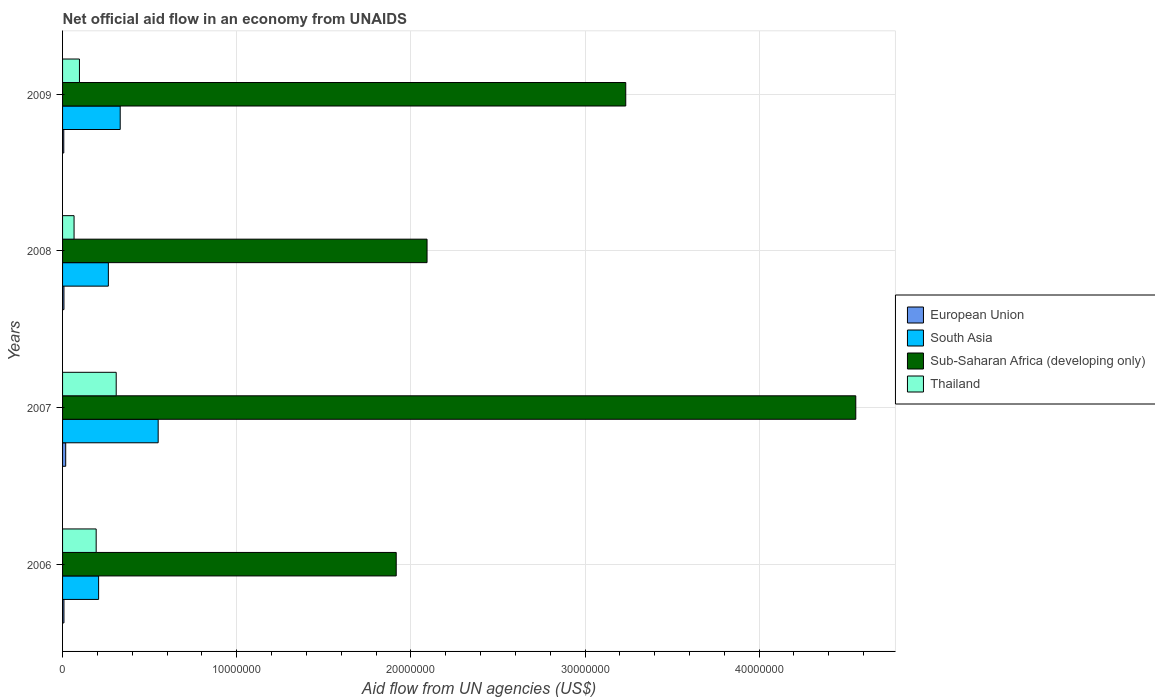How many groups of bars are there?
Offer a terse response. 4. Are the number of bars on each tick of the Y-axis equal?
Offer a terse response. Yes. How many bars are there on the 1st tick from the top?
Provide a succinct answer. 4. Across all years, what is the maximum net official aid flow in South Asia?
Your response must be concise. 5.49e+06. Across all years, what is the minimum net official aid flow in Sub-Saharan Africa (developing only)?
Give a very brief answer. 1.92e+07. What is the total net official aid flow in European Union in the graph?
Your response must be concise. 4.10e+05. What is the difference between the net official aid flow in Sub-Saharan Africa (developing only) in 2007 and that in 2009?
Give a very brief answer. 1.32e+07. What is the difference between the net official aid flow in European Union in 2006 and the net official aid flow in Sub-Saharan Africa (developing only) in 2008?
Keep it short and to the point. -2.08e+07. What is the average net official aid flow in European Union per year?
Ensure brevity in your answer.  1.02e+05. In the year 2008, what is the difference between the net official aid flow in Sub-Saharan Africa (developing only) and net official aid flow in European Union?
Make the answer very short. 2.08e+07. What is the ratio of the net official aid flow in European Union in 2008 to that in 2009?
Your answer should be very brief. 1.14. Is the net official aid flow in South Asia in 2006 less than that in 2009?
Your answer should be very brief. Yes. Is the difference between the net official aid flow in Sub-Saharan Africa (developing only) in 2006 and 2008 greater than the difference between the net official aid flow in European Union in 2006 and 2008?
Ensure brevity in your answer.  No. What is the difference between the highest and the lowest net official aid flow in South Asia?
Your answer should be compact. 3.42e+06. In how many years, is the net official aid flow in Thailand greater than the average net official aid flow in Thailand taken over all years?
Your response must be concise. 2. Is the sum of the net official aid flow in South Asia in 2007 and 2009 greater than the maximum net official aid flow in Sub-Saharan Africa (developing only) across all years?
Offer a very short reply. No. Is it the case that in every year, the sum of the net official aid flow in Thailand and net official aid flow in European Union is greater than the sum of net official aid flow in Sub-Saharan Africa (developing only) and net official aid flow in South Asia?
Offer a terse response. Yes. What does the 2nd bar from the top in 2008 represents?
Provide a short and direct response. Sub-Saharan Africa (developing only). Is it the case that in every year, the sum of the net official aid flow in South Asia and net official aid flow in Thailand is greater than the net official aid flow in European Union?
Keep it short and to the point. Yes. How many bars are there?
Give a very brief answer. 16. Does the graph contain grids?
Offer a very short reply. Yes. Where does the legend appear in the graph?
Give a very brief answer. Center right. How are the legend labels stacked?
Make the answer very short. Vertical. What is the title of the graph?
Ensure brevity in your answer.  Net official aid flow in an economy from UNAIDS. What is the label or title of the X-axis?
Keep it short and to the point. Aid flow from UN agencies (US$). What is the label or title of the Y-axis?
Offer a terse response. Years. What is the Aid flow from UN agencies (US$) of European Union in 2006?
Provide a short and direct response. 8.00e+04. What is the Aid flow from UN agencies (US$) of South Asia in 2006?
Offer a terse response. 2.07e+06. What is the Aid flow from UN agencies (US$) of Sub-Saharan Africa (developing only) in 2006?
Your answer should be compact. 1.92e+07. What is the Aid flow from UN agencies (US$) in Thailand in 2006?
Your response must be concise. 1.93e+06. What is the Aid flow from UN agencies (US$) in South Asia in 2007?
Your answer should be very brief. 5.49e+06. What is the Aid flow from UN agencies (US$) in Sub-Saharan Africa (developing only) in 2007?
Ensure brevity in your answer.  4.56e+07. What is the Aid flow from UN agencies (US$) in Thailand in 2007?
Provide a succinct answer. 3.08e+06. What is the Aid flow from UN agencies (US$) of European Union in 2008?
Offer a very short reply. 8.00e+04. What is the Aid flow from UN agencies (US$) of South Asia in 2008?
Offer a very short reply. 2.63e+06. What is the Aid flow from UN agencies (US$) of Sub-Saharan Africa (developing only) in 2008?
Your response must be concise. 2.09e+07. What is the Aid flow from UN agencies (US$) of European Union in 2009?
Your answer should be very brief. 7.00e+04. What is the Aid flow from UN agencies (US$) of South Asia in 2009?
Your answer should be very brief. 3.31e+06. What is the Aid flow from UN agencies (US$) of Sub-Saharan Africa (developing only) in 2009?
Make the answer very short. 3.23e+07. What is the Aid flow from UN agencies (US$) of Thailand in 2009?
Give a very brief answer. 9.70e+05. Across all years, what is the maximum Aid flow from UN agencies (US$) of South Asia?
Offer a terse response. 5.49e+06. Across all years, what is the maximum Aid flow from UN agencies (US$) of Sub-Saharan Africa (developing only)?
Offer a terse response. 4.56e+07. Across all years, what is the maximum Aid flow from UN agencies (US$) of Thailand?
Ensure brevity in your answer.  3.08e+06. Across all years, what is the minimum Aid flow from UN agencies (US$) of European Union?
Your response must be concise. 7.00e+04. Across all years, what is the minimum Aid flow from UN agencies (US$) in South Asia?
Keep it short and to the point. 2.07e+06. Across all years, what is the minimum Aid flow from UN agencies (US$) of Sub-Saharan Africa (developing only)?
Keep it short and to the point. 1.92e+07. What is the total Aid flow from UN agencies (US$) in South Asia in the graph?
Ensure brevity in your answer.  1.35e+07. What is the total Aid flow from UN agencies (US$) of Sub-Saharan Africa (developing only) in the graph?
Offer a very short reply. 1.18e+08. What is the total Aid flow from UN agencies (US$) of Thailand in the graph?
Offer a terse response. 6.64e+06. What is the difference between the Aid flow from UN agencies (US$) of South Asia in 2006 and that in 2007?
Your answer should be very brief. -3.42e+06. What is the difference between the Aid flow from UN agencies (US$) of Sub-Saharan Africa (developing only) in 2006 and that in 2007?
Make the answer very short. -2.64e+07. What is the difference between the Aid flow from UN agencies (US$) in Thailand in 2006 and that in 2007?
Ensure brevity in your answer.  -1.15e+06. What is the difference between the Aid flow from UN agencies (US$) of South Asia in 2006 and that in 2008?
Offer a very short reply. -5.60e+05. What is the difference between the Aid flow from UN agencies (US$) in Sub-Saharan Africa (developing only) in 2006 and that in 2008?
Ensure brevity in your answer.  -1.77e+06. What is the difference between the Aid flow from UN agencies (US$) in Thailand in 2006 and that in 2008?
Offer a terse response. 1.27e+06. What is the difference between the Aid flow from UN agencies (US$) in European Union in 2006 and that in 2009?
Your response must be concise. 10000. What is the difference between the Aid flow from UN agencies (US$) in South Asia in 2006 and that in 2009?
Keep it short and to the point. -1.24e+06. What is the difference between the Aid flow from UN agencies (US$) in Sub-Saharan Africa (developing only) in 2006 and that in 2009?
Give a very brief answer. -1.32e+07. What is the difference between the Aid flow from UN agencies (US$) of Thailand in 2006 and that in 2009?
Give a very brief answer. 9.60e+05. What is the difference between the Aid flow from UN agencies (US$) of South Asia in 2007 and that in 2008?
Provide a short and direct response. 2.86e+06. What is the difference between the Aid flow from UN agencies (US$) of Sub-Saharan Africa (developing only) in 2007 and that in 2008?
Offer a very short reply. 2.46e+07. What is the difference between the Aid flow from UN agencies (US$) in Thailand in 2007 and that in 2008?
Ensure brevity in your answer.  2.42e+06. What is the difference between the Aid flow from UN agencies (US$) in European Union in 2007 and that in 2009?
Provide a succinct answer. 1.10e+05. What is the difference between the Aid flow from UN agencies (US$) of South Asia in 2007 and that in 2009?
Ensure brevity in your answer.  2.18e+06. What is the difference between the Aid flow from UN agencies (US$) of Sub-Saharan Africa (developing only) in 2007 and that in 2009?
Make the answer very short. 1.32e+07. What is the difference between the Aid flow from UN agencies (US$) in Thailand in 2007 and that in 2009?
Keep it short and to the point. 2.11e+06. What is the difference between the Aid flow from UN agencies (US$) of South Asia in 2008 and that in 2009?
Your answer should be very brief. -6.80e+05. What is the difference between the Aid flow from UN agencies (US$) of Sub-Saharan Africa (developing only) in 2008 and that in 2009?
Give a very brief answer. -1.14e+07. What is the difference between the Aid flow from UN agencies (US$) in Thailand in 2008 and that in 2009?
Offer a very short reply. -3.10e+05. What is the difference between the Aid flow from UN agencies (US$) in European Union in 2006 and the Aid flow from UN agencies (US$) in South Asia in 2007?
Your answer should be very brief. -5.41e+06. What is the difference between the Aid flow from UN agencies (US$) of European Union in 2006 and the Aid flow from UN agencies (US$) of Sub-Saharan Africa (developing only) in 2007?
Keep it short and to the point. -4.55e+07. What is the difference between the Aid flow from UN agencies (US$) of European Union in 2006 and the Aid flow from UN agencies (US$) of Thailand in 2007?
Your response must be concise. -3.00e+06. What is the difference between the Aid flow from UN agencies (US$) of South Asia in 2006 and the Aid flow from UN agencies (US$) of Sub-Saharan Africa (developing only) in 2007?
Give a very brief answer. -4.35e+07. What is the difference between the Aid flow from UN agencies (US$) of South Asia in 2006 and the Aid flow from UN agencies (US$) of Thailand in 2007?
Make the answer very short. -1.01e+06. What is the difference between the Aid flow from UN agencies (US$) in Sub-Saharan Africa (developing only) in 2006 and the Aid flow from UN agencies (US$) in Thailand in 2007?
Your answer should be very brief. 1.61e+07. What is the difference between the Aid flow from UN agencies (US$) of European Union in 2006 and the Aid flow from UN agencies (US$) of South Asia in 2008?
Offer a very short reply. -2.55e+06. What is the difference between the Aid flow from UN agencies (US$) in European Union in 2006 and the Aid flow from UN agencies (US$) in Sub-Saharan Africa (developing only) in 2008?
Provide a short and direct response. -2.08e+07. What is the difference between the Aid flow from UN agencies (US$) of European Union in 2006 and the Aid flow from UN agencies (US$) of Thailand in 2008?
Provide a succinct answer. -5.80e+05. What is the difference between the Aid flow from UN agencies (US$) in South Asia in 2006 and the Aid flow from UN agencies (US$) in Sub-Saharan Africa (developing only) in 2008?
Ensure brevity in your answer.  -1.89e+07. What is the difference between the Aid flow from UN agencies (US$) in South Asia in 2006 and the Aid flow from UN agencies (US$) in Thailand in 2008?
Offer a very short reply. 1.41e+06. What is the difference between the Aid flow from UN agencies (US$) in Sub-Saharan Africa (developing only) in 2006 and the Aid flow from UN agencies (US$) in Thailand in 2008?
Keep it short and to the point. 1.85e+07. What is the difference between the Aid flow from UN agencies (US$) of European Union in 2006 and the Aid flow from UN agencies (US$) of South Asia in 2009?
Your answer should be compact. -3.23e+06. What is the difference between the Aid flow from UN agencies (US$) of European Union in 2006 and the Aid flow from UN agencies (US$) of Sub-Saharan Africa (developing only) in 2009?
Ensure brevity in your answer.  -3.23e+07. What is the difference between the Aid flow from UN agencies (US$) of European Union in 2006 and the Aid flow from UN agencies (US$) of Thailand in 2009?
Your answer should be very brief. -8.90e+05. What is the difference between the Aid flow from UN agencies (US$) in South Asia in 2006 and the Aid flow from UN agencies (US$) in Sub-Saharan Africa (developing only) in 2009?
Make the answer very short. -3.03e+07. What is the difference between the Aid flow from UN agencies (US$) of South Asia in 2006 and the Aid flow from UN agencies (US$) of Thailand in 2009?
Ensure brevity in your answer.  1.10e+06. What is the difference between the Aid flow from UN agencies (US$) of Sub-Saharan Africa (developing only) in 2006 and the Aid flow from UN agencies (US$) of Thailand in 2009?
Your answer should be very brief. 1.82e+07. What is the difference between the Aid flow from UN agencies (US$) in European Union in 2007 and the Aid flow from UN agencies (US$) in South Asia in 2008?
Your response must be concise. -2.45e+06. What is the difference between the Aid flow from UN agencies (US$) of European Union in 2007 and the Aid flow from UN agencies (US$) of Sub-Saharan Africa (developing only) in 2008?
Your answer should be compact. -2.08e+07. What is the difference between the Aid flow from UN agencies (US$) in European Union in 2007 and the Aid flow from UN agencies (US$) in Thailand in 2008?
Offer a terse response. -4.80e+05. What is the difference between the Aid flow from UN agencies (US$) of South Asia in 2007 and the Aid flow from UN agencies (US$) of Sub-Saharan Africa (developing only) in 2008?
Keep it short and to the point. -1.54e+07. What is the difference between the Aid flow from UN agencies (US$) of South Asia in 2007 and the Aid flow from UN agencies (US$) of Thailand in 2008?
Your response must be concise. 4.83e+06. What is the difference between the Aid flow from UN agencies (US$) in Sub-Saharan Africa (developing only) in 2007 and the Aid flow from UN agencies (US$) in Thailand in 2008?
Keep it short and to the point. 4.49e+07. What is the difference between the Aid flow from UN agencies (US$) of European Union in 2007 and the Aid flow from UN agencies (US$) of South Asia in 2009?
Offer a very short reply. -3.13e+06. What is the difference between the Aid flow from UN agencies (US$) in European Union in 2007 and the Aid flow from UN agencies (US$) in Sub-Saharan Africa (developing only) in 2009?
Ensure brevity in your answer.  -3.22e+07. What is the difference between the Aid flow from UN agencies (US$) in European Union in 2007 and the Aid flow from UN agencies (US$) in Thailand in 2009?
Provide a succinct answer. -7.90e+05. What is the difference between the Aid flow from UN agencies (US$) of South Asia in 2007 and the Aid flow from UN agencies (US$) of Sub-Saharan Africa (developing only) in 2009?
Your answer should be compact. -2.68e+07. What is the difference between the Aid flow from UN agencies (US$) in South Asia in 2007 and the Aid flow from UN agencies (US$) in Thailand in 2009?
Offer a terse response. 4.52e+06. What is the difference between the Aid flow from UN agencies (US$) in Sub-Saharan Africa (developing only) in 2007 and the Aid flow from UN agencies (US$) in Thailand in 2009?
Offer a very short reply. 4.46e+07. What is the difference between the Aid flow from UN agencies (US$) in European Union in 2008 and the Aid flow from UN agencies (US$) in South Asia in 2009?
Keep it short and to the point. -3.23e+06. What is the difference between the Aid flow from UN agencies (US$) of European Union in 2008 and the Aid flow from UN agencies (US$) of Sub-Saharan Africa (developing only) in 2009?
Your answer should be compact. -3.23e+07. What is the difference between the Aid flow from UN agencies (US$) in European Union in 2008 and the Aid flow from UN agencies (US$) in Thailand in 2009?
Provide a succinct answer. -8.90e+05. What is the difference between the Aid flow from UN agencies (US$) in South Asia in 2008 and the Aid flow from UN agencies (US$) in Sub-Saharan Africa (developing only) in 2009?
Provide a succinct answer. -2.97e+07. What is the difference between the Aid flow from UN agencies (US$) in South Asia in 2008 and the Aid flow from UN agencies (US$) in Thailand in 2009?
Keep it short and to the point. 1.66e+06. What is the difference between the Aid flow from UN agencies (US$) in Sub-Saharan Africa (developing only) in 2008 and the Aid flow from UN agencies (US$) in Thailand in 2009?
Your answer should be very brief. 2.00e+07. What is the average Aid flow from UN agencies (US$) in European Union per year?
Keep it short and to the point. 1.02e+05. What is the average Aid flow from UN agencies (US$) of South Asia per year?
Keep it short and to the point. 3.38e+06. What is the average Aid flow from UN agencies (US$) in Sub-Saharan Africa (developing only) per year?
Make the answer very short. 2.95e+07. What is the average Aid flow from UN agencies (US$) of Thailand per year?
Provide a succinct answer. 1.66e+06. In the year 2006, what is the difference between the Aid flow from UN agencies (US$) of European Union and Aid flow from UN agencies (US$) of South Asia?
Make the answer very short. -1.99e+06. In the year 2006, what is the difference between the Aid flow from UN agencies (US$) of European Union and Aid flow from UN agencies (US$) of Sub-Saharan Africa (developing only)?
Your response must be concise. -1.91e+07. In the year 2006, what is the difference between the Aid flow from UN agencies (US$) of European Union and Aid flow from UN agencies (US$) of Thailand?
Offer a terse response. -1.85e+06. In the year 2006, what is the difference between the Aid flow from UN agencies (US$) of South Asia and Aid flow from UN agencies (US$) of Sub-Saharan Africa (developing only)?
Offer a terse response. -1.71e+07. In the year 2006, what is the difference between the Aid flow from UN agencies (US$) in Sub-Saharan Africa (developing only) and Aid flow from UN agencies (US$) in Thailand?
Offer a very short reply. 1.72e+07. In the year 2007, what is the difference between the Aid flow from UN agencies (US$) in European Union and Aid flow from UN agencies (US$) in South Asia?
Your response must be concise. -5.31e+06. In the year 2007, what is the difference between the Aid flow from UN agencies (US$) of European Union and Aid flow from UN agencies (US$) of Sub-Saharan Africa (developing only)?
Ensure brevity in your answer.  -4.54e+07. In the year 2007, what is the difference between the Aid flow from UN agencies (US$) in European Union and Aid flow from UN agencies (US$) in Thailand?
Your answer should be compact. -2.90e+06. In the year 2007, what is the difference between the Aid flow from UN agencies (US$) of South Asia and Aid flow from UN agencies (US$) of Sub-Saharan Africa (developing only)?
Your response must be concise. -4.01e+07. In the year 2007, what is the difference between the Aid flow from UN agencies (US$) of South Asia and Aid flow from UN agencies (US$) of Thailand?
Provide a short and direct response. 2.41e+06. In the year 2007, what is the difference between the Aid flow from UN agencies (US$) in Sub-Saharan Africa (developing only) and Aid flow from UN agencies (US$) in Thailand?
Give a very brief answer. 4.25e+07. In the year 2008, what is the difference between the Aid flow from UN agencies (US$) of European Union and Aid flow from UN agencies (US$) of South Asia?
Provide a succinct answer. -2.55e+06. In the year 2008, what is the difference between the Aid flow from UN agencies (US$) of European Union and Aid flow from UN agencies (US$) of Sub-Saharan Africa (developing only)?
Make the answer very short. -2.08e+07. In the year 2008, what is the difference between the Aid flow from UN agencies (US$) of European Union and Aid flow from UN agencies (US$) of Thailand?
Give a very brief answer. -5.80e+05. In the year 2008, what is the difference between the Aid flow from UN agencies (US$) of South Asia and Aid flow from UN agencies (US$) of Sub-Saharan Africa (developing only)?
Ensure brevity in your answer.  -1.83e+07. In the year 2008, what is the difference between the Aid flow from UN agencies (US$) in South Asia and Aid flow from UN agencies (US$) in Thailand?
Offer a terse response. 1.97e+06. In the year 2008, what is the difference between the Aid flow from UN agencies (US$) in Sub-Saharan Africa (developing only) and Aid flow from UN agencies (US$) in Thailand?
Keep it short and to the point. 2.03e+07. In the year 2009, what is the difference between the Aid flow from UN agencies (US$) of European Union and Aid flow from UN agencies (US$) of South Asia?
Make the answer very short. -3.24e+06. In the year 2009, what is the difference between the Aid flow from UN agencies (US$) of European Union and Aid flow from UN agencies (US$) of Sub-Saharan Africa (developing only)?
Keep it short and to the point. -3.23e+07. In the year 2009, what is the difference between the Aid flow from UN agencies (US$) in European Union and Aid flow from UN agencies (US$) in Thailand?
Ensure brevity in your answer.  -9.00e+05. In the year 2009, what is the difference between the Aid flow from UN agencies (US$) in South Asia and Aid flow from UN agencies (US$) in Sub-Saharan Africa (developing only)?
Your response must be concise. -2.90e+07. In the year 2009, what is the difference between the Aid flow from UN agencies (US$) in South Asia and Aid flow from UN agencies (US$) in Thailand?
Your answer should be very brief. 2.34e+06. In the year 2009, what is the difference between the Aid flow from UN agencies (US$) in Sub-Saharan Africa (developing only) and Aid flow from UN agencies (US$) in Thailand?
Provide a succinct answer. 3.14e+07. What is the ratio of the Aid flow from UN agencies (US$) in European Union in 2006 to that in 2007?
Ensure brevity in your answer.  0.44. What is the ratio of the Aid flow from UN agencies (US$) of South Asia in 2006 to that in 2007?
Give a very brief answer. 0.38. What is the ratio of the Aid flow from UN agencies (US$) in Sub-Saharan Africa (developing only) in 2006 to that in 2007?
Provide a short and direct response. 0.42. What is the ratio of the Aid flow from UN agencies (US$) of Thailand in 2006 to that in 2007?
Provide a succinct answer. 0.63. What is the ratio of the Aid flow from UN agencies (US$) of South Asia in 2006 to that in 2008?
Your answer should be compact. 0.79. What is the ratio of the Aid flow from UN agencies (US$) of Sub-Saharan Africa (developing only) in 2006 to that in 2008?
Your answer should be very brief. 0.92. What is the ratio of the Aid flow from UN agencies (US$) in Thailand in 2006 to that in 2008?
Ensure brevity in your answer.  2.92. What is the ratio of the Aid flow from UN agencies (US$) in South Asia in 2006 to that in 2009?
Ensure brevity in your answer.  0.63. What is the ratio of the Aid flow from UN agencies (US$) of Sub-Saharan Africa (developing only) in 2006 to that in 2009?
Your response must be concise. 0.59. What is the ratio of the Aid flow from UN agencies (US$) of Thailand in 2006 to that in 2009?
Offer a very short reply. 1.99. What is the ratio of the Aid flow from UN agencies (US$) in European Union in 2007 to that in 2008?
Offer a very short reply. 2.25. What is the ratio of the Aid flow from UN agencies (US$) in South Asia in 2007 to that in 2008?
Ensure brevity in your answer.  2.09. What is the ratio of the Aid flow from UN agencies (US$) in Sub-Saharan Africa (developing only) in 2007 to that in 2008?
Your answer should be compact. 2.18. What is the ratio of the Aid flow from UN agencies (US$) in Thailand in 2007 to that in 2008?
Provide a succinct answer. 4.67. What is the ratio of the Aid flow from UN agencies (US$) in European Union in 2007 to that in 2009?
Offer a terse response. 2.57. What is the ratio of the Aid flow from UN agencies (US$) in South Asia in 2007 to that in 2009?
Make the answer very short. 1.66. What is the ratio of the Aid flow from UN agencies (US$) in Sub-Saharan Africa (developing only) in 2007 to that in 2009?
Provide a short and direct response. 1.41. What is the ratio of the Aid flow from UN agencies (US$) in Thailand in 2007 to that in 2009?
Offer a very short reply. 3.18. What is the ratio of the Aid flow from UN agencies (US$) in South Asia in 2008 to that in 2009?
Offer a very short reply. 0.79. What is the ratio of the Aid flow from UN agencies (US$) of Sub-Saharan Africa (developing only) in 2008 to that in 2009?
Your response must be concise. 0.65. What is the ratio of the Aid flow from UN agencies (US$) in Thailand in 2008 to that in 2009?
Your answer should be compact. 0.68. What is the difference between the highest and the second highest Aid flow from UN agencies (US$) in European Union?
Offer a terse response. 1.00e+05. What is the difference between the highest and the second highest Aid flow from UN agencies (US$) in South Asia?
Ensure brevity in your answer.  2.18e+06. What is the difference between the highest and the second highest Aid flow from UN agencies (US$) of Sub-Saharan Africa (developing only)?
Provide a succinct answer. 1.32e+07. What is the difference between the highest and the second highest Aid flow from UN agencies (US$) of Thailand?
Your response must be concise. 1.15e+06. What is the difference between the highest and the lowest Aid flow from UN agencies (US$) of South Asia?
Offer a very short reply. 3.42e+06. What is the difference between the highest and the lowest Aid flow from UN agencies (US$) in Sub-Saharan Africa (developing only)?
Provide a short and direct response. 2.64e+07. What is the difference between the highest and the lowest Aid flow from UN agencies (US$) in Thailand?
Ensure brevity in your answer.  2.42e+06. 